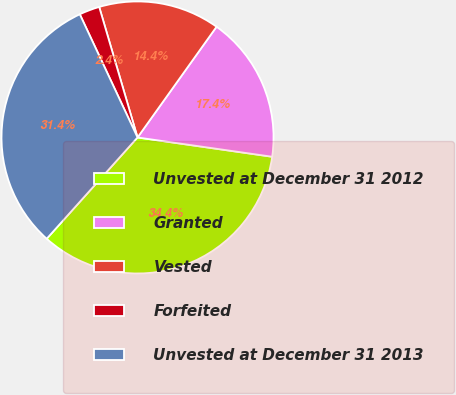Convert chart to OTSL. <chart><loc_0><loc_0><loc_500><loc_500><pie_chart><fcel>Unvested at December 31 2012<fcel>Granted<fcel>Vested<fcel>Forfeited<fcel>Unvested at December 31 2013<nl><fcel>34.37%<fcel>17.4%<fcel>14.41%<fcel>2.43%<fcel>31.39%<nl></chart> 